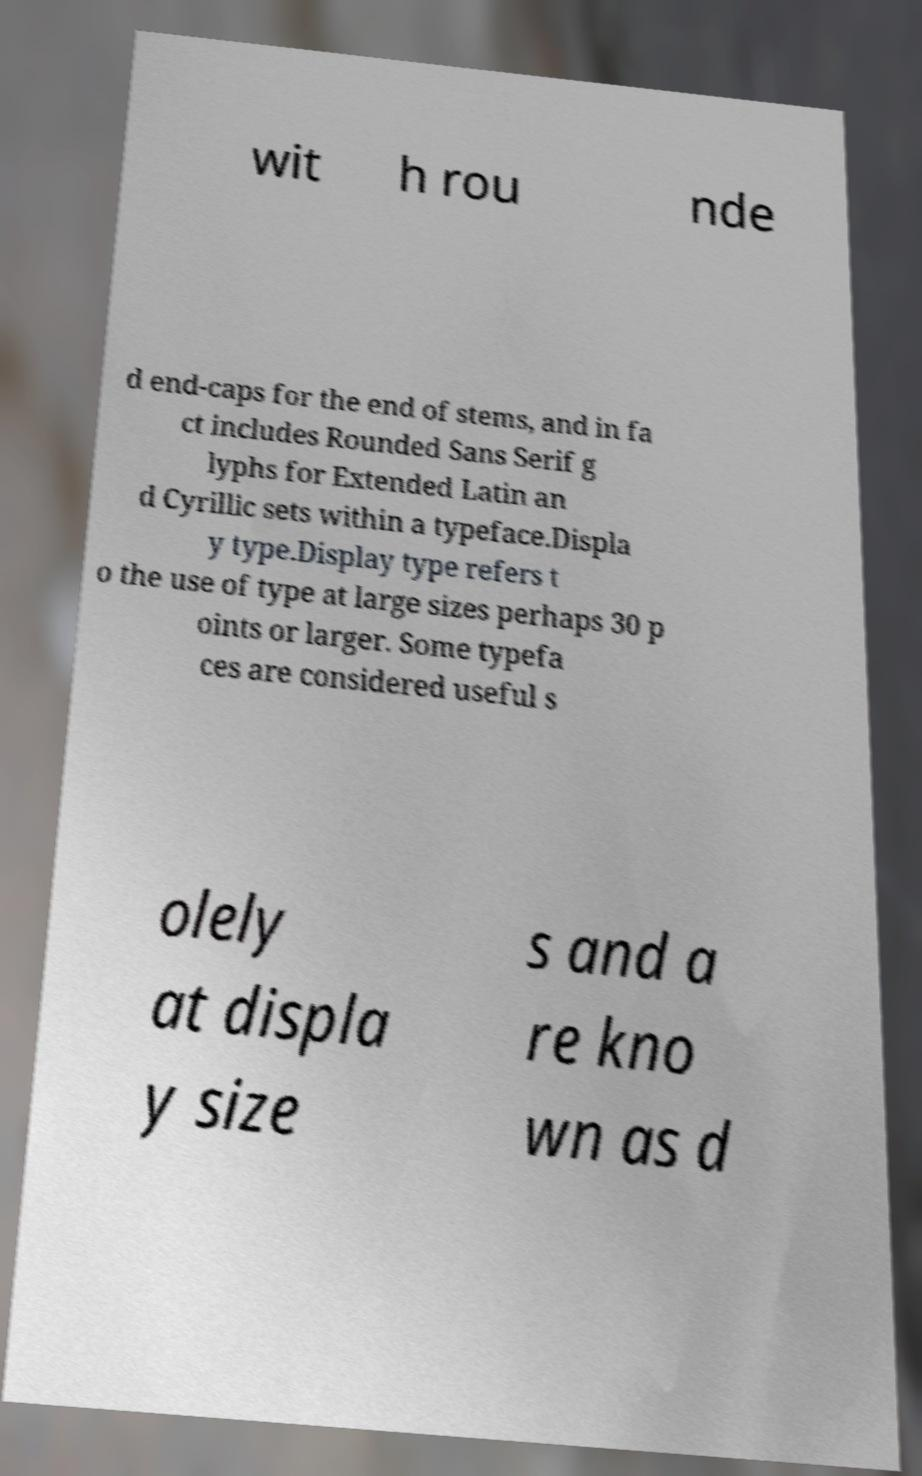Could you extract and type out the text from this image? wit h rou nde d end-caps for the end of stems, and in fa ct includes Rounded Sans Serif g lyphs for Extended Latin an d Cyrillic sets within a typeface.Displa y type.Display type refers t o the use of type at large sizes perhaps 30 p oints or larger. Some typefa ces are considered useful s olely at displa y size s and a re kno wn as d 